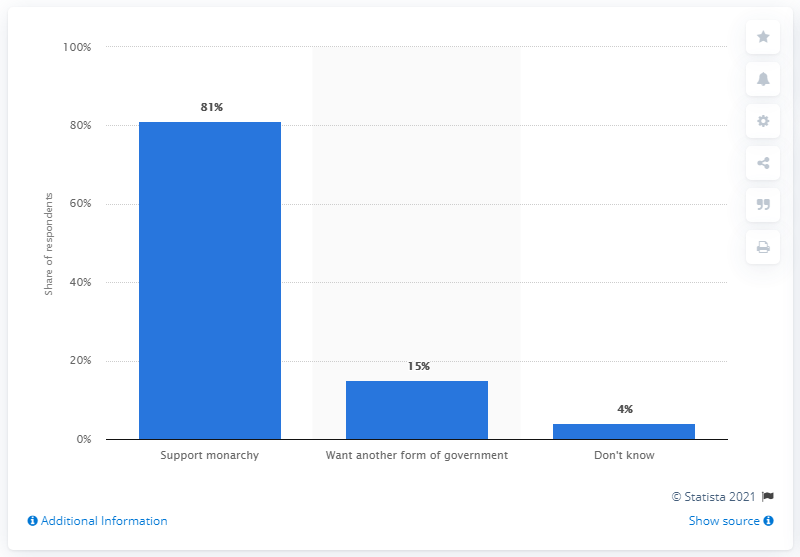Mention a couple of crucial points in this snapshot. According to a recent survey, 15% of Norwegians expressed a desire for a different form of government. 